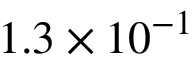<formula> <loc_0><loc_0><loc_500><loc_500>1 . 3 \times 1 0 ^ { - 1 }</formula> 